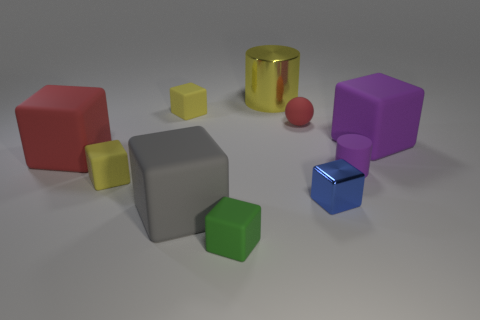Subtract all gray blocks. How many blocks are left? 6 Subtract all big gray rubber blocks. How many blocks are left? 6 Subtract 3 blocks. How many blocks are left? 4 Subtract all green blocks. Subtract all cyan spheres. How many blocks are left? 6 Subtract all balls. How many objects are left? 9 Subtract all small red rubber balls. Subtract all small yellow cubes. How many objects are left? 7 Add 1 large gray things. How many large gray things are left? 2 Add 4 shiny things. How many shiny things exist? 6 Subtract 0 brown spheres. How many objects are left? 10 